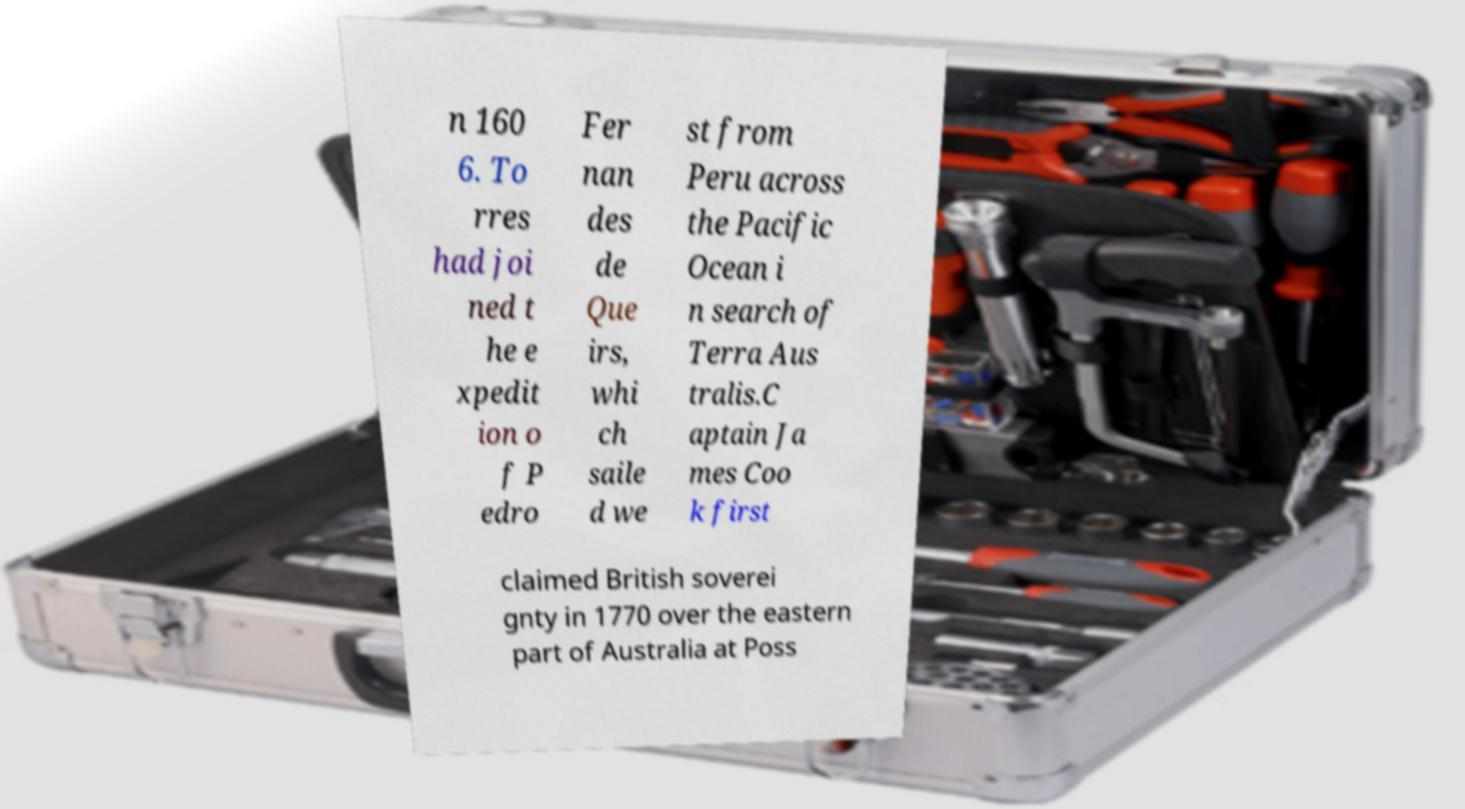I need the written content from this picture converted into text. Can you do that? n 160 6. To rres had joi ned t he e xpedit ion o f P edro Fer nan des de Que irs, whi ch saile d we st from Peru across the Pacific Ocean i n search of Terra Aus tralis.C aptain Ja mes Coo k first claimed British soverei gnty in 1770 over the eastern part of Australia at Poss 